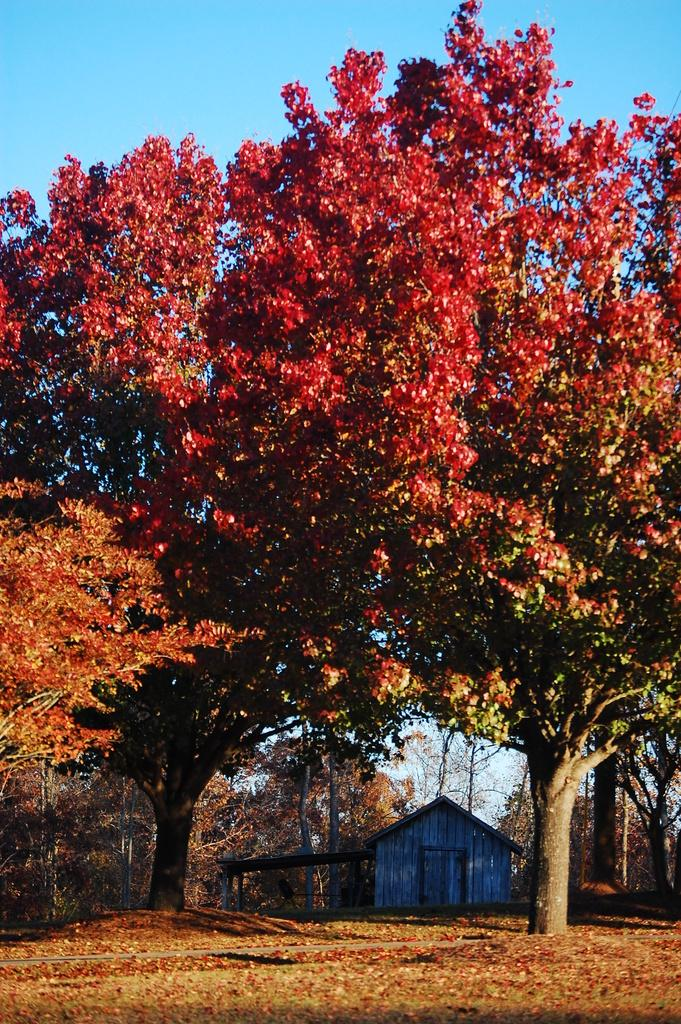What type of vegetation can be seen on the grassy land in the image? There are trees on the grassy land in the image. What else can be found on the grassy land besides trees? Leaves are present on the land. What type of structure is visible in the image? There is a wooden house in the image. What can be seen in the background of the image? The sky is visible in the background of the image. Can you see a fan in the image? There is no fan present in the image. What type of substance is being used by the giraffe in the image? There is no giraffe present in the image. 